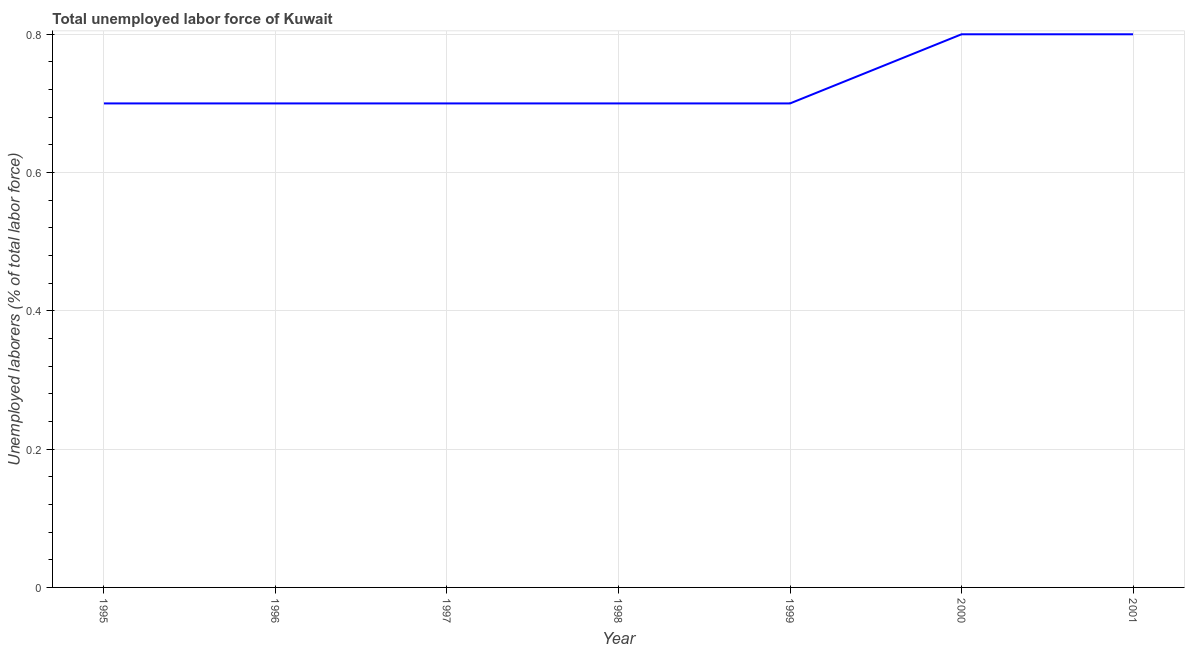What is the total unemployed labour force in 1997?
Your answer should be compact. 0.7. Across all years, what is the maximum total unemployed labour force?
Offer a terse response. 0.8. Across all years, what is the minimum total unemployed labour force?
Give a very brief answer. 0.7. In which year was the total unemployed labour force maximum?
Keep it short and to the point. 2000. What is the sum of the total unemployed labour force?
Keep it short and to the point. 5.1. What is the difference between the total unemployed labour force in 1996 and 1997?
Make the answer very short. 0. What is the average total unemployed labour force per year?
Make the answer very short. 0.73. What is the median total unemployed labour force?
Offer a very short reply. 0.7. What is the ratio of the total unemployed labour force in 2000 to that in 2001?
Provide a succinct answer. 1. What is the difference between the highest and the second highest total unemployed labour force?
Provide a short and direct response. 0. What is the difference between the highest and the lowest total unemployed labour force?
Make the answer very short. 0.1. Does the total unemployed labour force monotonically increase over the years?
Provide a short and direct response. No. How many lines are there?
Your answer should be very brief. 1. What is the difference between two consecutive major ticks on the Y-axis?
Provide a short and direct response. 0.2. What is the title of the graph?
Give a very brief answer. Total unemployed labor force of Kuwait. What is the label or title of the X-axis?
Provide a short and direct response. Year. What is the label or title of the Y-axis?
Your response must be concise. Unemployed laborers (% of total labor force). What is the Unemployed laborers (% of total labor force) in 1995?
Offer a terse response. 0.7. What is the Unemployed laborers (% of total labor force) in 1996?
Give a very brief answer. 0.7. What is the Unemployed laborers (% of total labor force) of 1997?
Your answer should be very brief. 0.7. What is the Unemployed laborers (% of total labor force) in 1998?
Offer a very short reply. 0.7. What is the Unemployed laborers (% of total labor force) in 1999?
Give a very brief answer. 0.7. What is the Unemployed laborers (% of total labor force) of 2000?
Ensure brevity in your answer.  0.8. What is the Unemployed laborers (% of total labor force) in 2001?
Ensure brevity in your answer.  0.8. What is the difference between the Unemployed laborers (% of total labor force) in 1995 and 1996?
Your response must be concise. 0. What is the difference between the Unemployed laborers (% of total labor force) in 1995 and 1998?
Provide a short and direct response. 0. What is the difference between the Unemployed laborers (% of total labor force) in 1996 and 1998?
Provide a succinct answer. 0. What is the difference between the Unemployed laborers (% of total labor force) in 1996 and 2000?
Make the answer very short. -0.1. What is the difference between the Unemployed laborers (% of total labor force) in 1997 and 1998?
Offer a very short reply. 0. What is the difference between the Unemployed laborers (% of total labor force) in 1997 and 2000?
Provide a succinct answer. -0.1. What is the difference between the Unemployed laborers (% of total labor force) in 1998 and 1999?
Provide a succinct answer. 0. What is the difference between the Unemployed laborers (% of total labor force) in 1999 and 2001?
Provide a succinct answer. -0.1. What is the difference between the Unemployed laborers (% of total labor force) in 2000 and 2001?
Keep it short and to the point. 0. What is the ratio of the Unemployed laborers (% of total labor force) in 1995 to that in 1996?
Provide a short and direct response. 1. What is the ratio of the Unemployed laborers (% of total labor force) in 1995 to that in 1999?
Your answer should be compact. 1. What is the ratio of the Unemployed laborers (% of total labor force) in 1995 to that in 2000?
Offer a very short reply. 0.88. What is the ratio of the Unemployed laborers (% of total labor force) in 1995 to that in 2001?
Make the answer very short. 0.88. What is the ratio of the Unemployed laborers (% of total labor force) in 1996 to that in 1997?
Provide a succinct answer. 1. What is the ratio of the Unemployed laborers (% of total labor force) in 1996 to that in 2000?
Your answer should be very brief. 0.88. What is the ratio of the Unemployed laborers (% of total labor force) in 1996 to that in 2001?
Offer a very short reply. 0.88. What is the ratio of the Unemployed laborers (% of total labor force) in 1997 to that in 1999?
Make the answer very short. 1. What is the ratio of the Unemployed laborers (% of total labor force) in 1997 to that in 2000?
Your answer should be very brief. 0.88. What is the ratio of the Unemployed laborers (% of total labor force) in 1997 to that in 2001?
Provide a short and direct response. 0.88. What is the ratio of the Unemployed laborers (% of total labor force) in 1998 to that in 1999?
Your answer should be very brief. 1. What is the ratio of the Unemployed laborers (% of total labor force) in 1998 to that in 2001?
Ensure brevity in your answer.  0.88. What is the ratio of the Unemployed laborers (% of total labor force) in 2000 to that in 2001?
Provide a succinct answer. 1. 